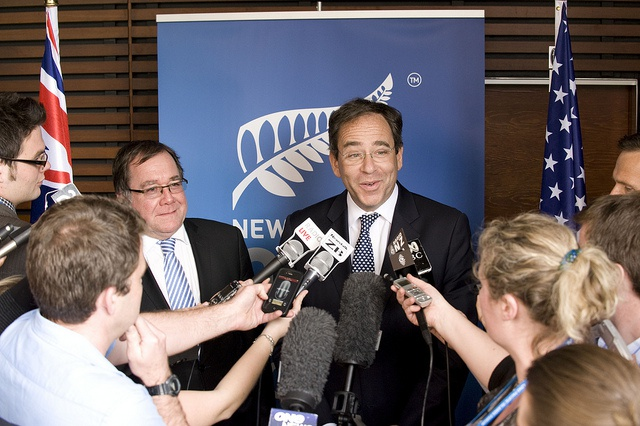Describe the objects in this image and their specific colors. I can see people in maroon, white, gray, and black tones, people in maroon, black, tan, white, and gray tones, people in maroon, tan, and gray tones, people in maroon, black, white, lightpink, and gray tones, and people in maroon, black, tan, and gray tones in this image. 